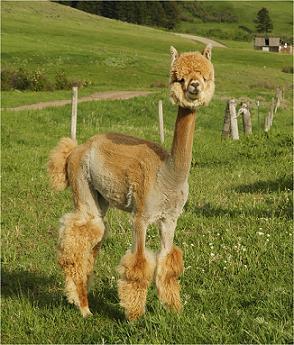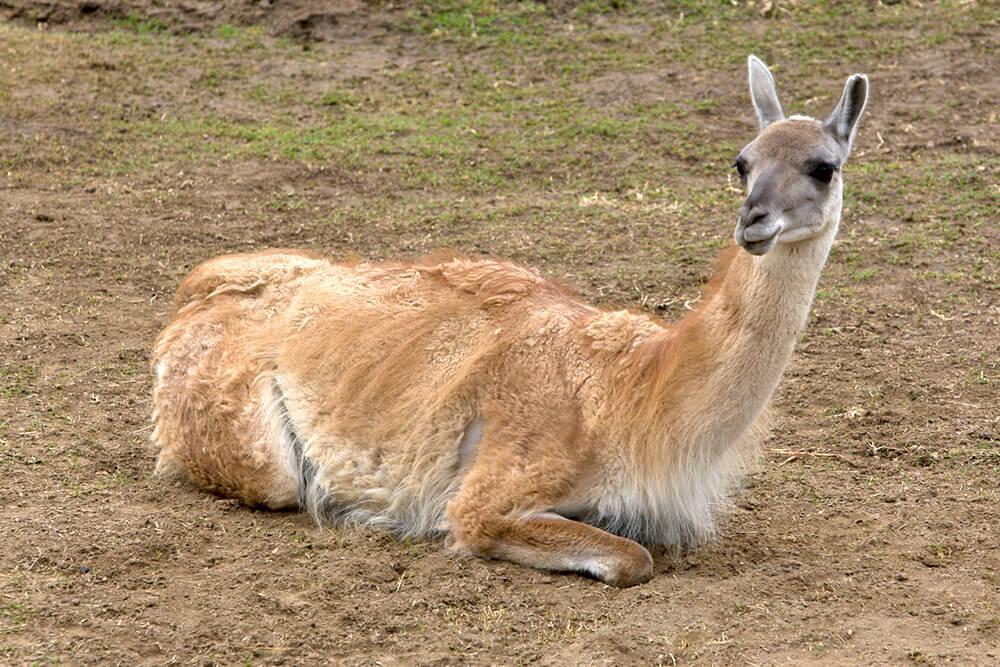The first image is the image on the left, the second image is the image on the right. Given the left and right images, does the statement "In one of the images, the llama has a leash on his neck." hold true? Answer yes or no. No. The first image is the image on the left, the second image is the image on the right. For the images displayed, is the sentence "Each image contains one llama lying on the ground, and the left image features a brown-and-white llma with a pink harness and a rope at its tail end lying on its side on the grass." factually correct? Answer yes or no. No. 